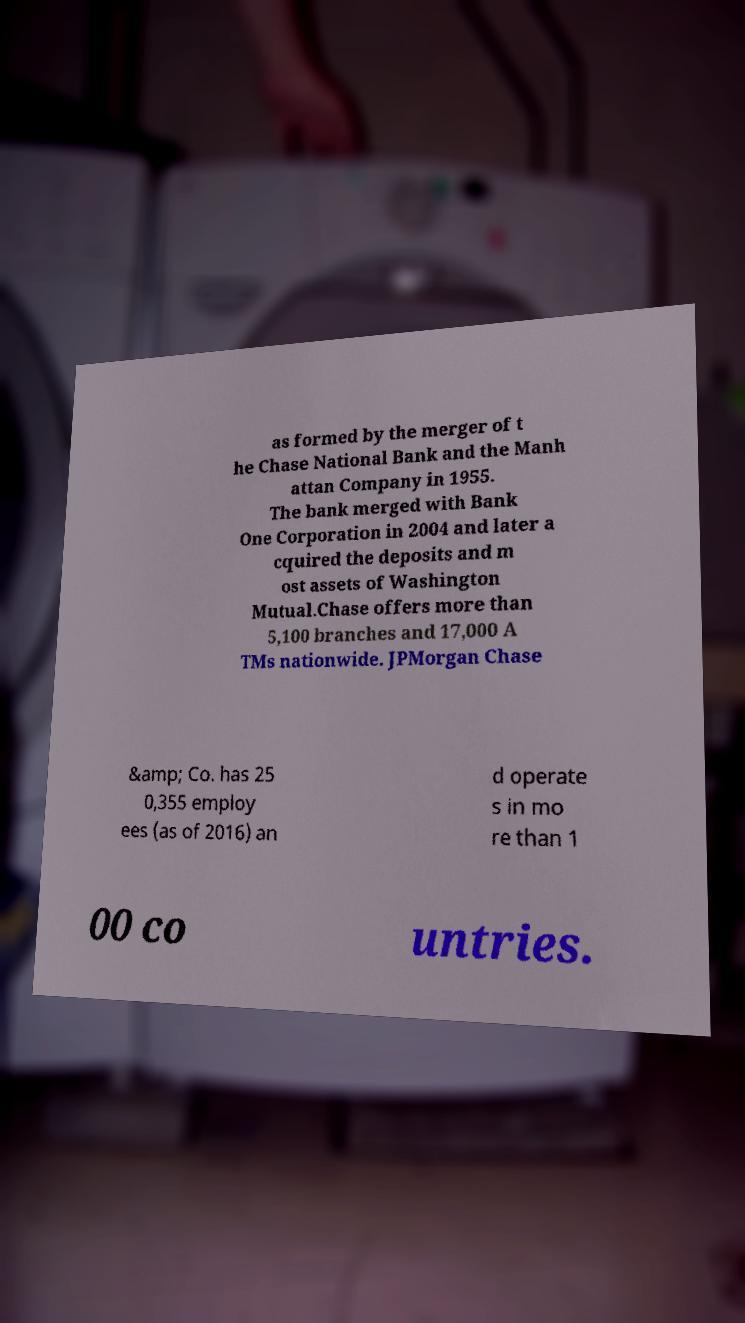There's text embedded in this image that I need extracted. Can you transcribe it verbatim? as formed by the merger of t he Chase National Bank and the Manh attan Company in 1955. The bank merged with Bank One Corporation in 2004 and later a cquired the deposits and m ost assets of Washington Mutual.Chase offers more than 5,100 branches and 17,000 A TMs nationwide. JPMorgan Chase &amp; Co. has 25 0,355 employ ees (as of 2016) an d operate s in mo re than 1 00 co untries. 